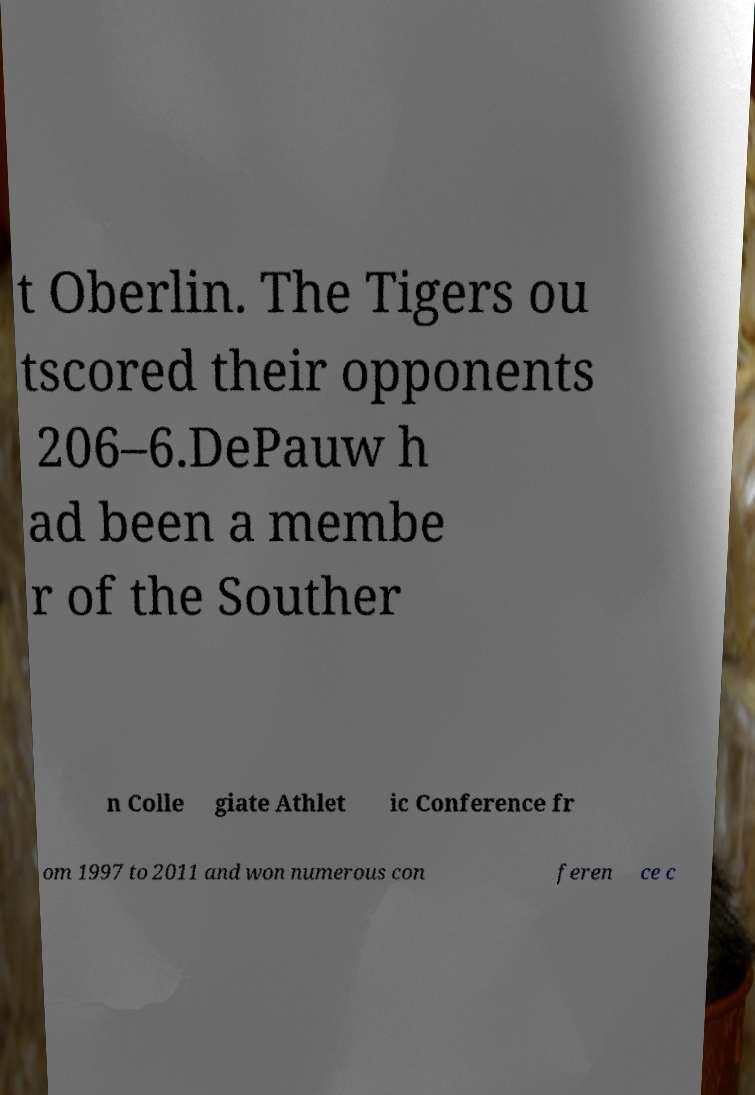Please identify and transcribe the text found in this image. t Oberlin. The Tigers ou tscored their opponents 206–6.DePauw h ad been a membe r of the Souther n Colle giate Athlet ic Conference fr om 1997 to 2011 and won numerous con feren ce c 